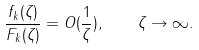<formula> <loc_0><loc_0><loc_500><loc_500>\frac { f _ { k } ( \zeta ) } { F _ { k } ( \zeta ) } = O ( \frac { 1 } { \zeta } ) , \quad \zeta \rightarrow \infty .</formula> 